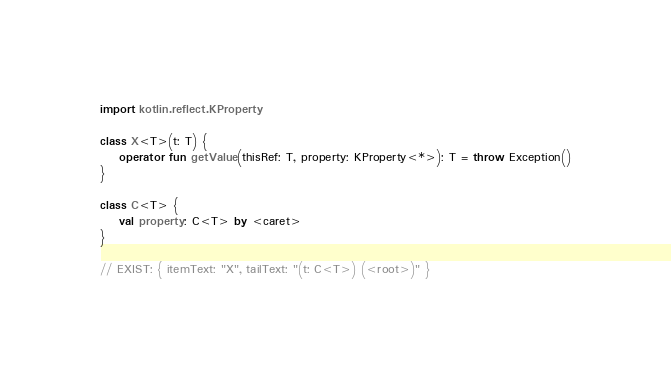Convert code to text. <code><loc_0><loc_0><loc_500><loc_500><_Kotlin_>import kotlin.reflect.KProperty

class X<T>(t: T) {
    operator fun getValue(thisRef: T, property: KProperty<*>): T = throw Exception()
}

class C<T> {
    val property: C<T> by <caret>
}

// EXIST: { itemText: "X", tailText: "(t: C<T>) (<root>)" }
</code> 